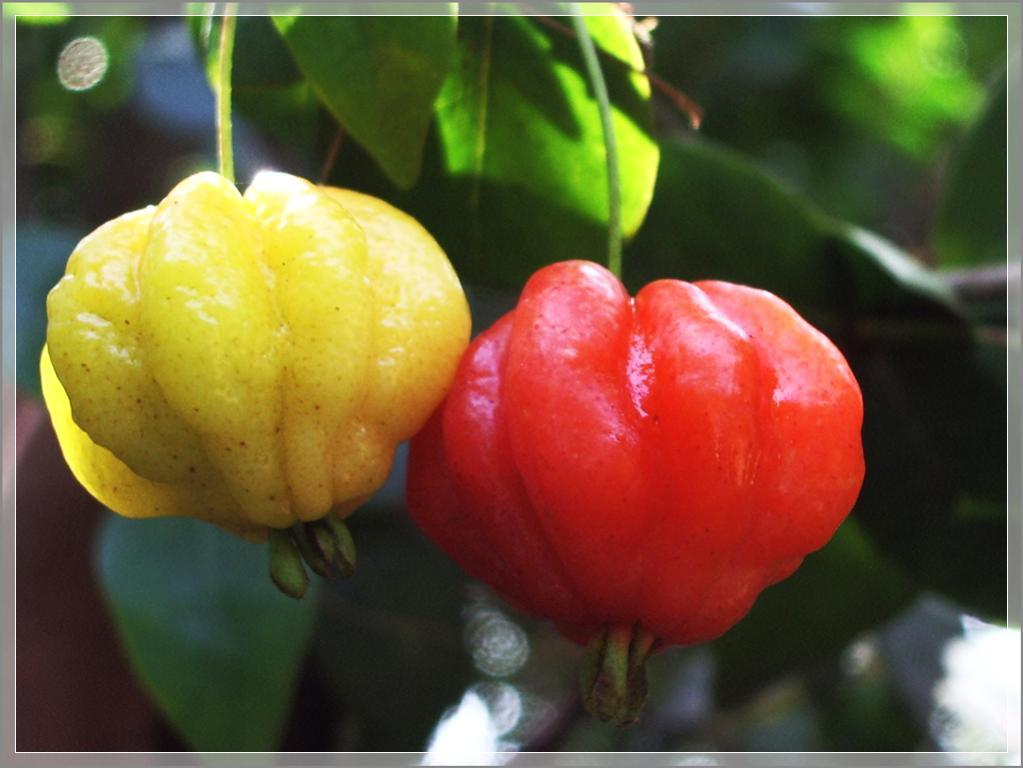How many fruits are in the picture? There are two fruits in the picture. What colors are the fruits? One fruit is yellow in color, and the other fruit is red in color. Do the fruits have any common features? Yes, both fruits have stems. How would you describe the background of the image? The background of the image is blurred. Can you see any mittens in the picture? No, there are no mittens present in the image. Is there a park visible in the background of the image? No, there is no park visible in the image; the background is blurred. 